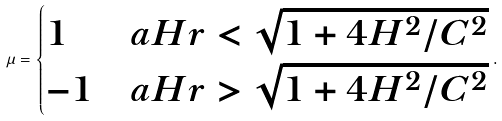<formula> <loc_0><loc_0><loc_500><loc_500>\mu = \begin{cases} 1 & a H r < \sqrt { 1 + 4 H ^ { 2 } / C ^ { 2 } } \\ - 1 & a H r > \sqrt { 1 + 4 H ^ { 2 } / C ^ { 2 } } \end{cases} .</formula> 